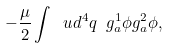<formula> <loc_0><loc_0><loc_500><loc_500>- \frac { \mu } { 2 } \int \ u d ^ { 4 } q \ g ^ { 1 } _ { a } \phi g ^ { 2 } _ { a } \phi ,</formula> 